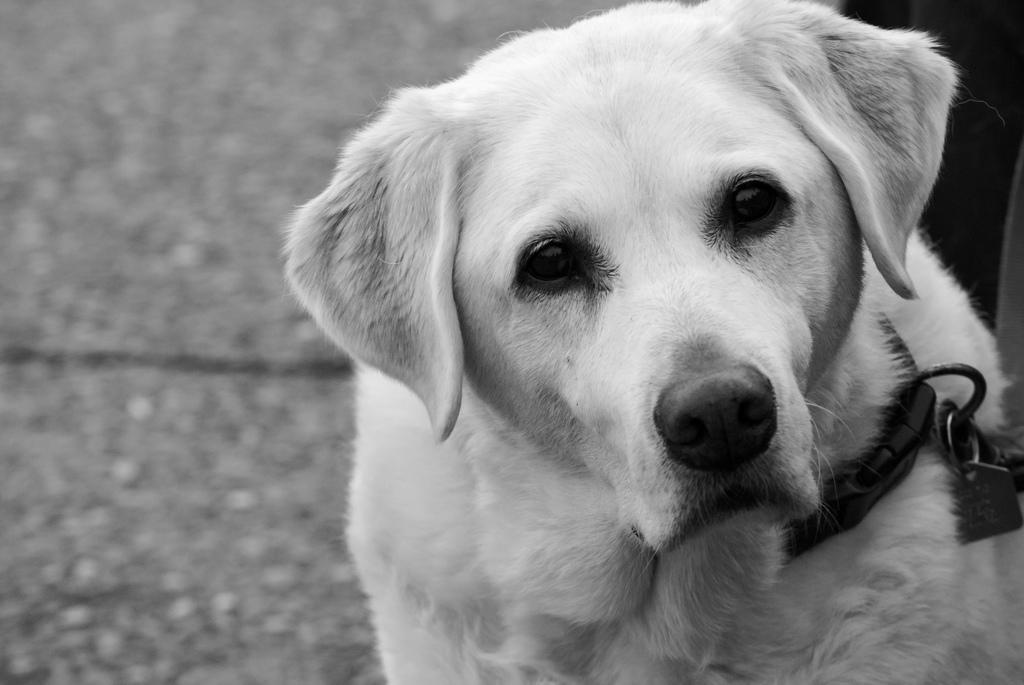Could you give a brief overview of what you see in this image? In this picture there is a white dog with belt around the neck. At the bottom there is a floor. 